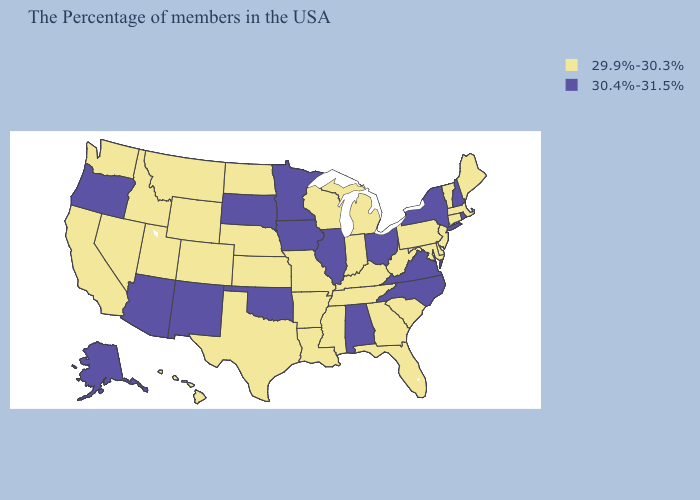Does the first symbol in the legend represent the smallest category?
Be succinct. Yes. Does Oklahoma have the lowest value in the South?
Keep it brief. No. Name the states that have a value in the range 29.9%-30.3%?
Concise answer only. Maine, Massachusetts, Vermont, Connecticut, New Jersey, Delaware, Maryland, Pennsylvania, South Carolina, West Virginia, Florida, Georgia, Michigan, Kentucky, Indiana, Tennessee, Wisconsin, Mississippi, Louisiana, Missouri, Arkansas, Kansas, Nebraska, Texas, North Dakota, Wyoming, Colorado, Utah, Montana, Idaho, Nevada, California, Washington, Hawaii. Does Illinois have the highest value in the MidWest?
Give a very brief answer. Yes. Among the states that border Iowa , does Missouri have the highest value?
Concise answer only. No. Does the map have missing data?
Give a very brief answer. No. Is the legend a continuous bar?
Concise answer only. No. Does South Dakota have the highest value in the USA?
Be succinct. Yes. What is the value of California?
Answer briefly. 29.9%-30.3%. Among the states that border West Virginia , does Maryland have the highest value?
Concise answer only. No. What is the value of Kansas?
Keep it brief. 29.9%-30.3%. What is the value of Louisiana?
Keep it brief. 29.9%-30.3%. Name the states that have a value in the range 30.4%-31.5%?
Keep it brief. Rhode Island, New Hampshire, New York, Virginia, North Carolina, Ohio, Alabama, Illinois, Minnesota, Iowa, Oklahoma, South Dakota, New Mexico, Arizona, Oregon, Alaska. What is the highest value in the USA?
Short answer required. 30.4%-31.5%. Does Utah have the lowest value in the USA?
Be succinct. Yes. 